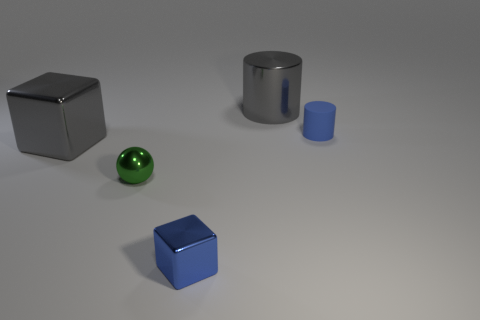Are there any gray metal objects that have the same size as the green ball?
Your answer should be compact. No. What shape is the small shiny thing that is the same color as the tiny rubber cylinder?
Provide a succinct answer. Cube. How many blue blocks have the same size as the metallic cylinder?
Ensure brevity in your answer.  0. There is a gray object that is in front of the gray metal cylinder; is its size the same as the gray metallic thing that is behind the big gray cube?
Provide a short and direct response. Yes. What number of objects are large brown matte balls or blocks that are right of the big cube?
Your response must be concise. 1. What color is the tiny cylinder?
Provide a succinct answer. Blue. There is a cube right of the large gray thing on the left side of the large gray metallic object to the right of the green metallic object; what is its material?
Ensure brevity in your answer.  Metal. There is a blue object that is the same material as the green ball; what size is it?
Your answer should be compact. Small. Are there any tiny metal cubes that have the same color as the sphere?
Give a very brief answer. No. There is a green object; does it have the same size as the blue thing behind the blue metallic block?
Offer a terse response. Yes. 